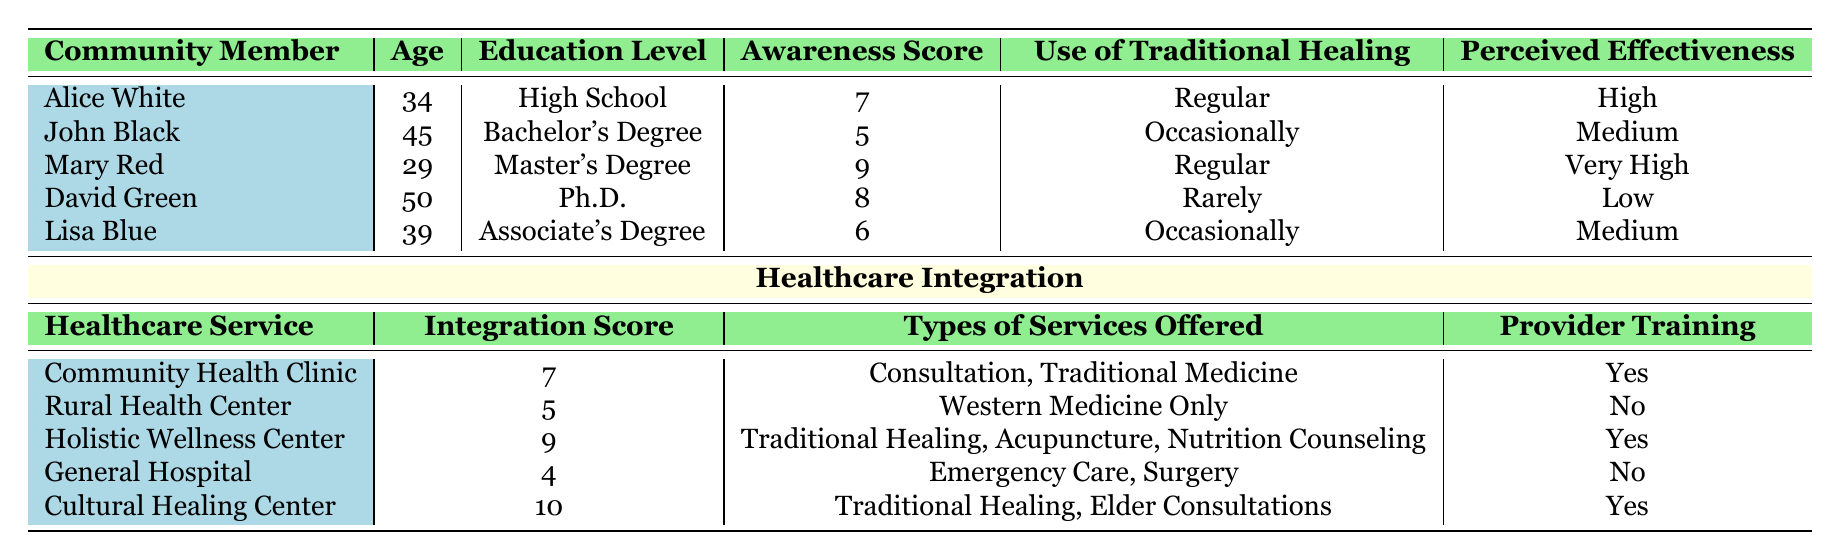What is the highest Awareness Score among the community members? The Awareness Scores are 7, 5, 9, 8, and 6. The highest value among these is 9, which corresponds to Mary Red.
Answer: 9 Which healthcare service has the highest Integration Score? The Integration Scores listed are 7, 5, 9, 4, and 10. The highest score is 10, which is associated with the Cultural Healing Center.
Answer: Cultural Healing Center How many community members perceive Traditional Healing as highly effective? The perceived effectiveness ratings are High, Medium, Very High, Low, and Medium. Only Alice White and Mary Red report high effectiveness, adding up to 2 members.
Answer: 2 Is there a healthcare service that offers Traditional Healing and has provider training in Traditional Healing? The Community Health Clinic and Cultural Healing Center both provide Traditional Healing and have "Yes" in provider training. This is true for both services.
Answer: Yes What is the average Awareness Score for the community members? To calculate the average, sum the Awareness Scores: (7 + 5 + 9 + 8 + 6) = 35. Divide by the number of members (5): 35/5 = 7.
Answer: 7 What age is Lisa Blue, and how does it compare to Mary Red's age? Lisa Blue is 39 years old and Mary Red is 29 years old. 39 is greater than 29, indicating that Lisa is 10 years older than Mary.
Answer: 39 (Lisa Blue is older) Does the Rural Health Center offer any services related to Traditional Healing? The Rural Health Center only offers Western Medicine, as stated in the types of services offered. Thus, there are no services related to Traditional Healing.
Answer: No What percentage of the community members use Traditional Healing regularly? There are 5 community members, and 2 of them (Alice White and Mary Red) use Traditional Healing regularly. To find the percentage, (2/5) * 100 = 40%.
Answer: 40% Which type of healthcare service offers the least Integration Score, and what services do they provide? The General Hospital has the lowest Integration Score of 4. The services offered are Emergency Care and Surgery.
Answer: General Hospital, Emergency Care and Surgery 